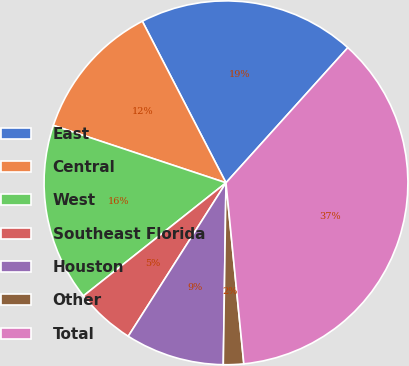<chart> <loc_0><loc_0><loc_500><loc_500><pie_chart><fcel>East<fcel>Central<fcel>West<fcel>Southeast Florida<fcel>Houston<fcel>Other<fcel>Total<nl><fcel>19.28%<fcel>12.29%<fcel>15.78%<fcel>5.3%<fcel>8.79%<fcel>1.8%<fcel>36.76%<nl></chart> 